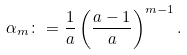Convert formula to latex. <formula><loc_0><loc_0><loc_500><loc_500>\alpha _ { m } \colon = \frac { 1 } { a } \left ( \frac { a - 1 } { a } \right ) ^ { m - 1 } .</formula> 